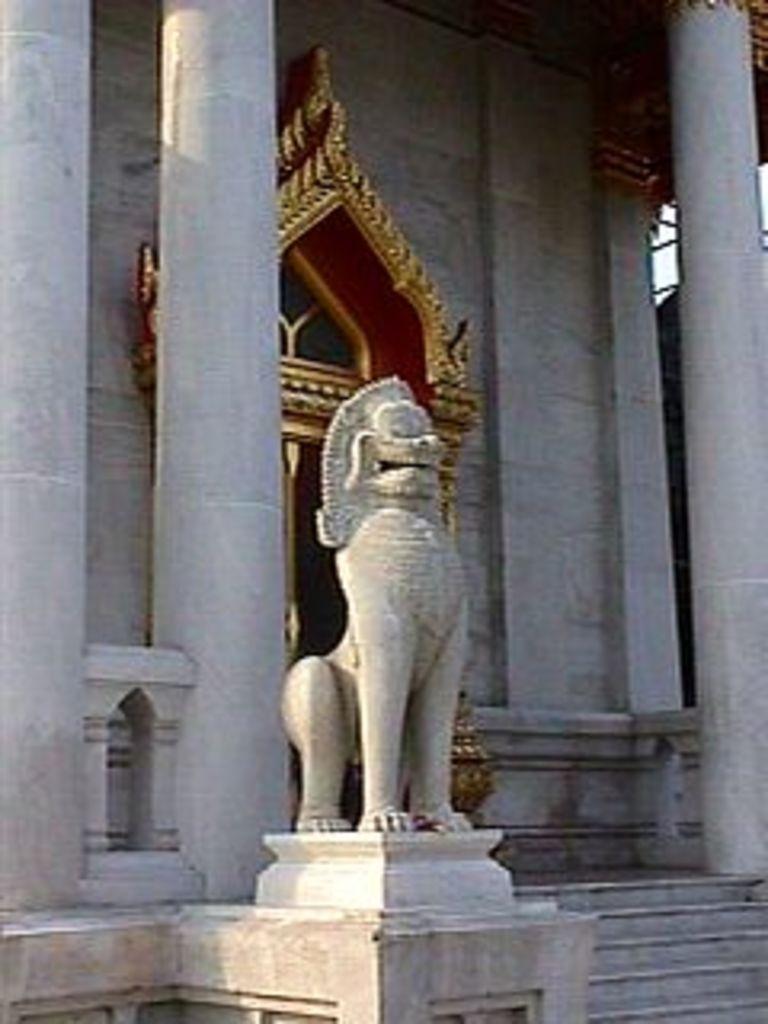Describe this image in one or two sentences. In this picture we can see sculpture on the platform. We can see steps, pillars wall and door. 